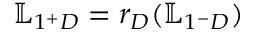<formula> <loc_0><loc_0><loc_500><loc_500>\mathbb { L } _ { 1 ^ { + } D } = r _ { D } ( \mathbb { L } _ { 1 ^ { - } D } )</formula> 